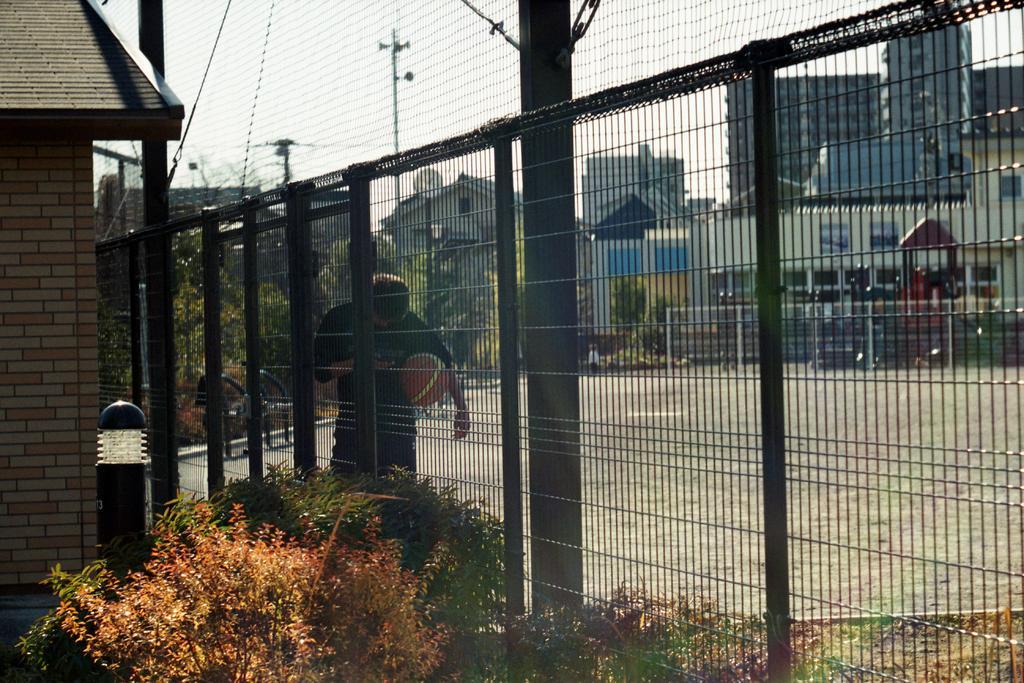How would you summarize this image in a sentence or two? At the bottom of the picture, we see plants and grass. Beside that, we see a fence and beside that, we see an electric pole and wires. In the middle of the picture, we see a man is standing and he is holding a brown color ball in his hand. Behind him, we see black chairs. On the left side, we see a pole and buildings. There are trees, buildings and electric poles in the background. 